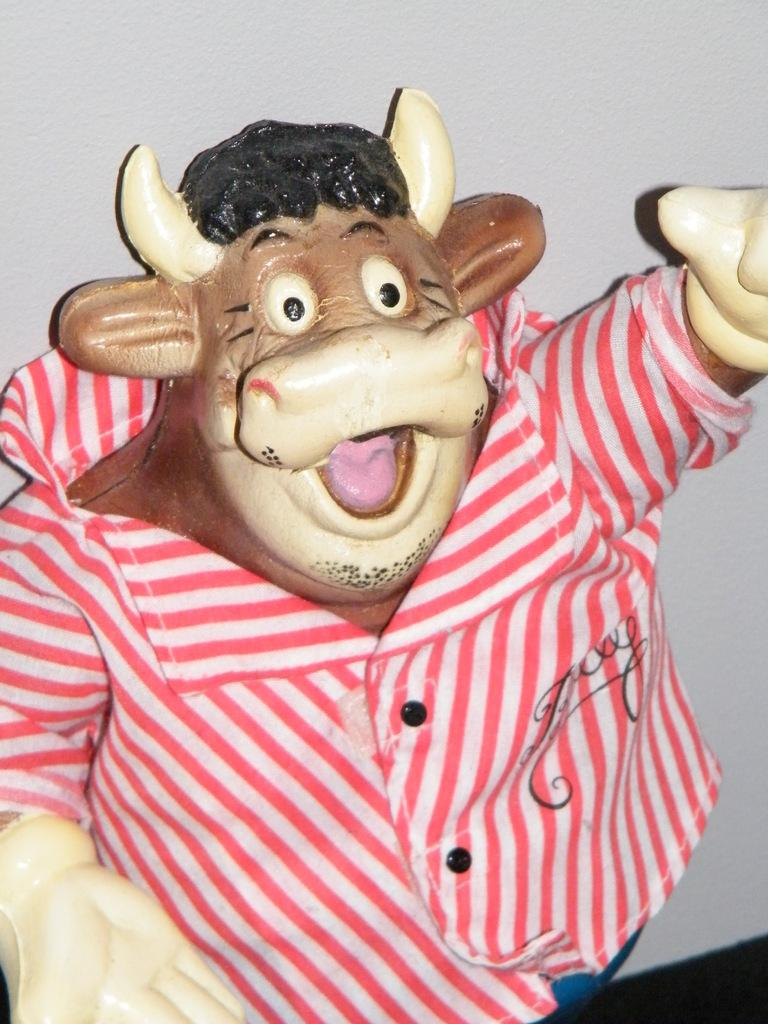What type of toy is in the image? There is a cow doll in the image. What is the cow doll wearing? The cow doll has a shirt. What is written on the shirt? There is writing on the shirt. What can be seen in the background of the image? There is a wall in the background of the image. What room is the cow doll in, and how do you know it's a room? The provided facts do not mention a room or any specific location for the cow doll. We cannot determine if it's in a room or any other type of space based on the given information. 